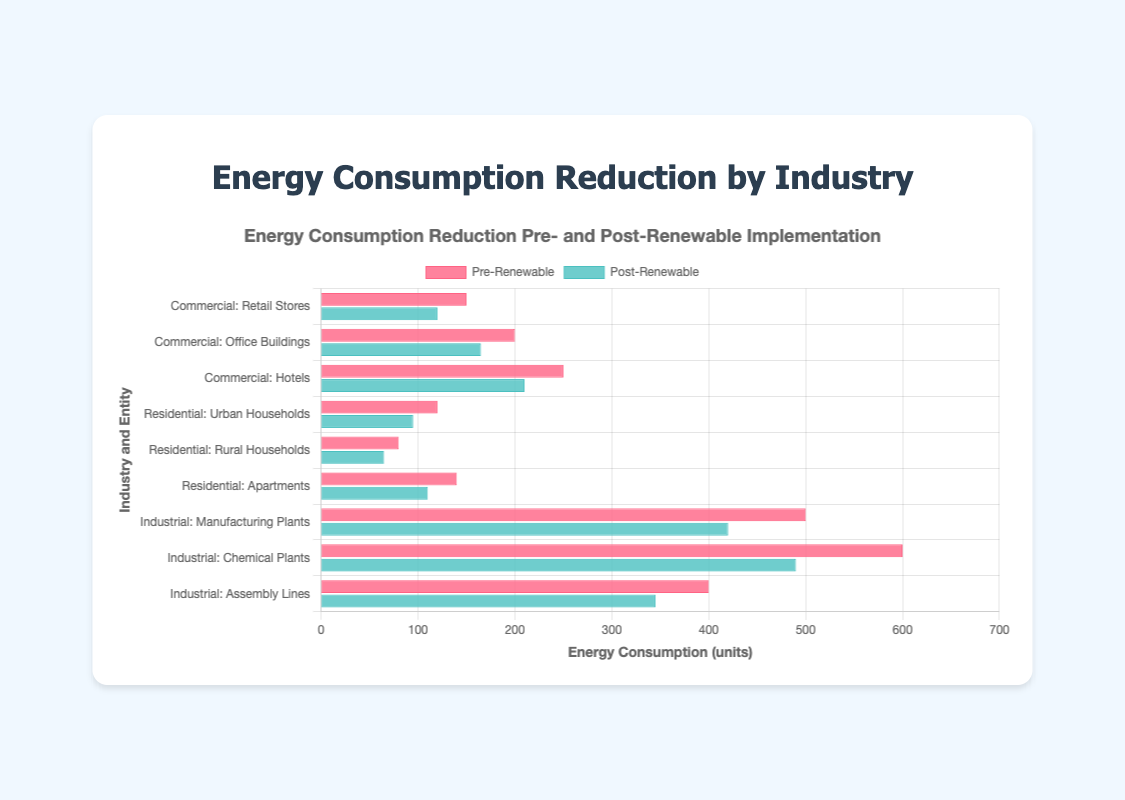Which industry saw the highest reduction in energy consumption after renewable energy implementation? The industry with the highest reduction is determined by comparing the differences (PreRenewable - PostRenewable) for each industry. For Commercial: Retail Stores (30), Office Buildings (35), Hotels (40); for Residential: Urban Households (25), Rural Households (15), Apartments (30); for Industrial: Manufacturing Plants (80), Chemical Plants (110), Assembly Lines (55). Industrial leads with Chemical Plants having the highest individual reduction of 110 units.
Answer: Industrial Which entity within the Industrial sector experienced the smallest reduction in energy consumption post-renewable energy implementation? To find the entity with the smallest reduction within the Industrial sector, compare the differences (PreRenewable - PostRenewable) for all Industrial entities: Manufacturing Plants (80), Chemical Plants (110), Assembly Lines (55). Assembly Lines has the smallest reduction of 55 units.
Answer: Assembly Lines What is the total reduction in energy consumption for all entities combined? Summing the differences (PreRenewable - PostRenewable) for all entries: Retail Stores (30), Office Buildings (35), Hotels (40), Urban Households (25), Rural Households (15), Apartments (30), Manufacturing Plants (80), Chemical Plants (110), Assembly Lines (55), the total reduction is 420 units.
Answer: 420 Which Residential entity has the largest reduction in energy consumption after renewable energy adoption? By comparing the differences (PreRenewable - PostRenewable) for Residential entities: Urban Households (25), Rural Households (15), Apartments (30). Apartments have the largest reduction with 30 units.
Answer: Apartments How does the energy reduction of Manufacturing Plants compare to that of Retail Stores? Calculate the reductions: Manufacturing Plants (500 - 420 = 80), Retail Stores (150 - 120 = 30). Manufacturing Plants reduced by 80 units, compared to Retail Stores which reduced by 30 units. Manufacturing Plants experienced a higher reduction by 50 units more.
Answer: 50 units more What is the average energy consumption reduction for Office Buildings and Hotels combined? Calculate the reductions: Office Buildings (35), Hotels (40). Sum is 35 + 40 = 75, and the average is 75 / 2 = 37.5 units.
Answer: 37.5 units Which entity within the Residential sector had the lowest post-renewable energy consumption? Comparing the post-renewable energy consumption figures: Urban Households (95), Rural Households (65), Apartments (110). Rural Households had the lowest post-renewable energy consumption with 65 units.
Answer: Rural Households By how much did the energy consumption of Chemical Plants reduce in absolute terms compared to Urban Households? Calculate the reductions: Chemical Plants (600 - 490 = 110), Urban Households (120 - 95 = 25). Chemical Plants reduced by 110 units, and Urban Households by 25 units. The absolute difference is 110 - 25 = 85 units.
Answer: 85 units 